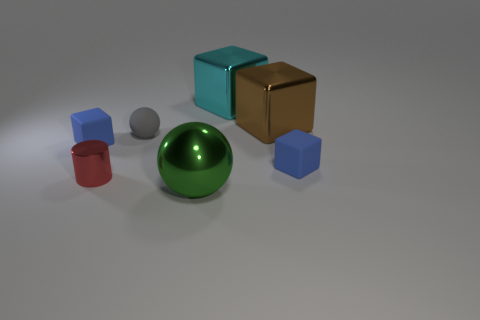What is the material of the brown object?
Your answer should be compact. Metal. There is a cyan block; are there any small cubes behind it?
Provide a succinct answer. No. What size is the other metal object that is the same shape as the big brown metallic object?
Your answer should be compact. Large. Are there the same number of small cylinders to the left of the red thing and tiny gray rubber balls in front of the green metal thing?
Keep it short and to the point. Yes. What number of large brown things are there?
Provide a short and direct response. 1. Are there more tiny blue rubber objects that are to the right of the tiny red shiny cylinder than big gray balls?
Ensure brevity in your answer.  Yes. There is a brown cube that is to the right of the big green shiny thing; what is its material?
Your answer should be compact. Metal. There is another big object that is the same shape as the big cyan metal object; what color is it?
Provide a succinct answer. Brown. Do the sphere behind the large green metallic object and the thing behind the big brown thing have the same size?
Offer a terse response. No. Is the size of the brown thing the same as the object that is in front of the metal cylinder?
Offer a terse response. Yes. 